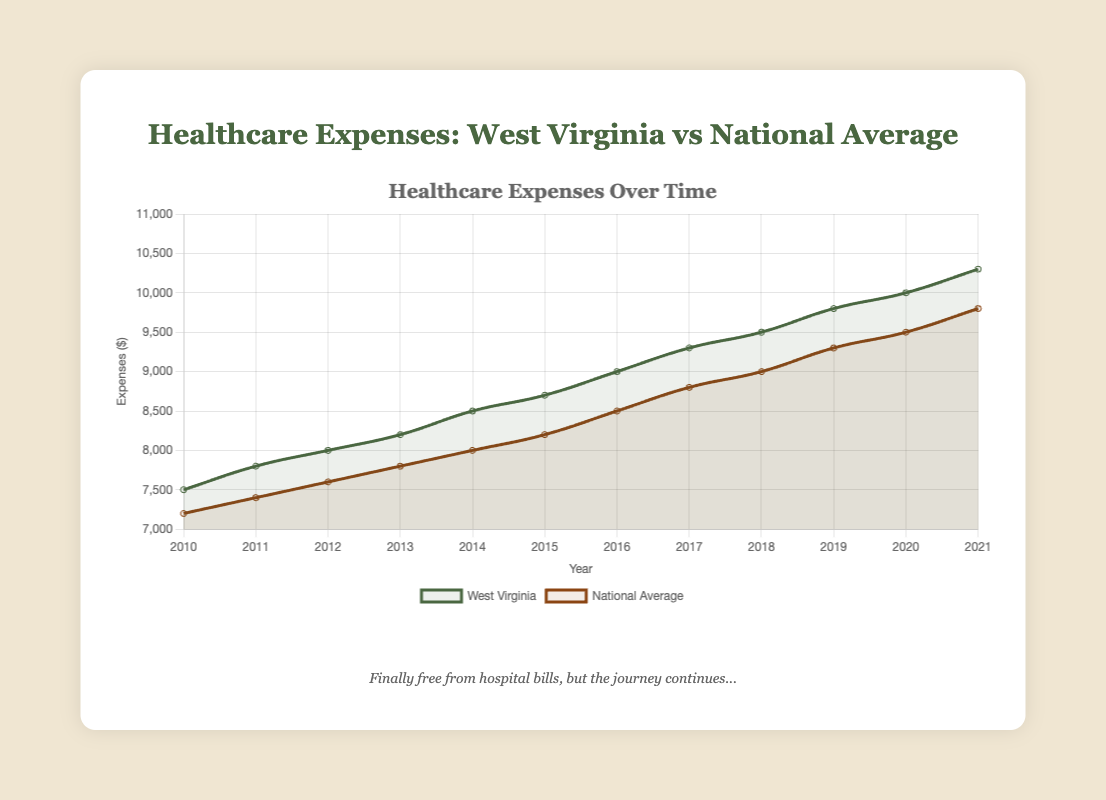What is the trend in healthcare expenses in West Virginia from 2010 to 2021? The trend in the West Virginia curve shows a steady increase in healthcare expenses each year from 2010 to 2021. The expenses rise consistently from $7,500 in 2010 to $10,300 in 2021.
Answer: Steady increase In which year did West Virginia's healthcare expenses first exceed $9,000? Looking at the West Virginia curve, the expenses first exceed $9,000 in the year 2016. In 2016, the expenses are exactly $9,000.
Answer: 2016 How much higher were West Virginia's healthcare expenses compared to the national average in 2021? In 2021, the healthcare expenses for West Virginia were $10,300 while the national average was $9,800. The difference is $10,300 - $9,800 = $500.
Answer: $500 What is the average increase in healthcare expenses per year for the national average from 2010 to 2021? The national average expenses go from $7,200 in 2010 to $9,800 in 2021. The total increase is $9,800 - $7,200 = $2,600. There are 11 intervals between 12 years, so the average increase per year is $2,600 / 11 = approximately $236.36.
Answer: $236.36 Between 2017 and 2018, which had a higher increase in expenses, West Virginia or the national average? For West Virginia, the expenses increased from $9,300 in 2017 to $9,500 in 2018, an increase by $200. For the national average, the expenses increased from $8,800 in 2017 to $9,000 in 2018, also an increase by $200. The increase is the same for both.
Answer: Same Which dataset's expenses show a more rapid increase in the period from 2010 to 2021? The West Virginia curve starts at $7,500 in 2010 and goes to $10,300 in 2021, an increase of $2,800. The national average starts at $7,200 in 2010 and goes to $9,800 in 2021, an increase of $2,600. So, the increase in West Virginia is higher.
Answer: West Virginia How did the national average expenses in 2015 compare to West Virginia's in the same year? In 2015, the healthcare expenses for the national average were $8,200, while for West Virginia, they were $8,700. West Virginia's expenses were $500 higher.
Answer: $500 higher By how much did West Virginia's healthcare expenses increase from 2019 to 2020? Looking at the West Virginia curve, the expenses in 2019 were $9,800 and in 2020 were $10,000. The difference is $10,000 - $9,800 = $200.
Answer: $200 Which year shows the smallest difference between West Virginia's expenses and the national average? Calculating the absolute differences for each year, the smallest difference occurs in 2015. In 2015, the difference is $8,700 (WV) - $8,200 (National) = $500.
Answer: 2015 